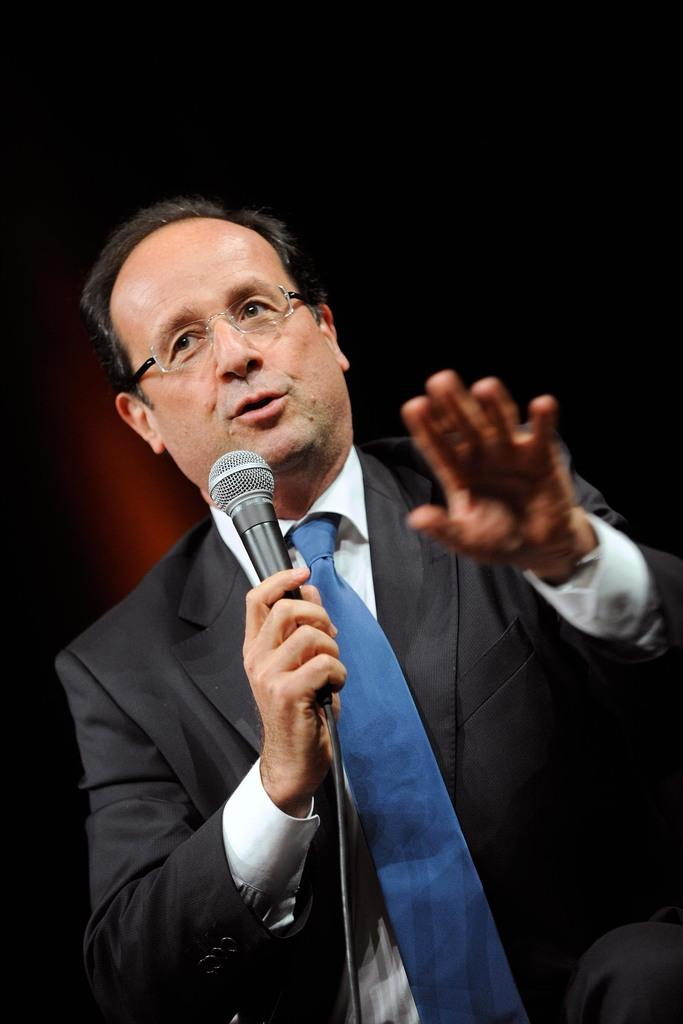Who is present in the image? There is a man in the image. What is the man doing in the image? The man is sitting in the image. What object is the man holding in his hand? The man is holding a mic in his hand. Can you see the man's grandmother in the image? There is no mention of a grandmother in the image, so it cannot be determined if she is present. 